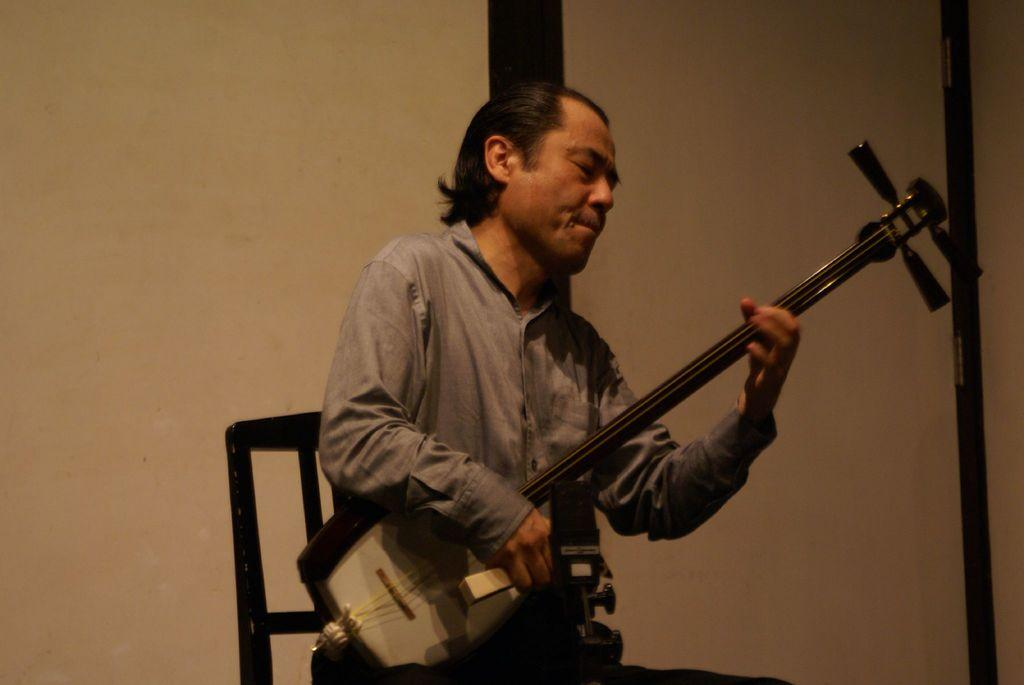What can be seen in the background of the image? There is a wall in the background of the image. Is there any opening in the wall? Yes, there appears to be a door in the wall. What is the man in the image doing? The man is sitting on a chair and playing a musical instrument. Can you point out the map on the wall in the image? There is no map present on the wall in the image. What season is it in the image, considering the man is playing a musical instrument? The season cannot be determined from the image, as there are no seasonal indicators present. 